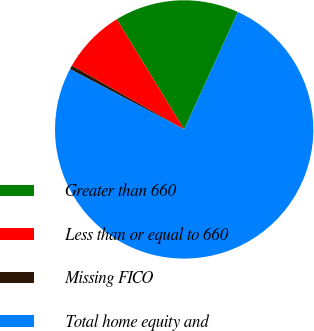Convert chart. <chart><loc_0><loc_0><loc_500><loc_500><pie_chart><fcel>Greater than 660<fcel>Less than or equal to 660<fcel>Missing FICO<fcel>Total home equity and<nl><fcel>15.57%<fcel>8.03%<fcel>0.49%<fcel>75.91%<nl></chart> 